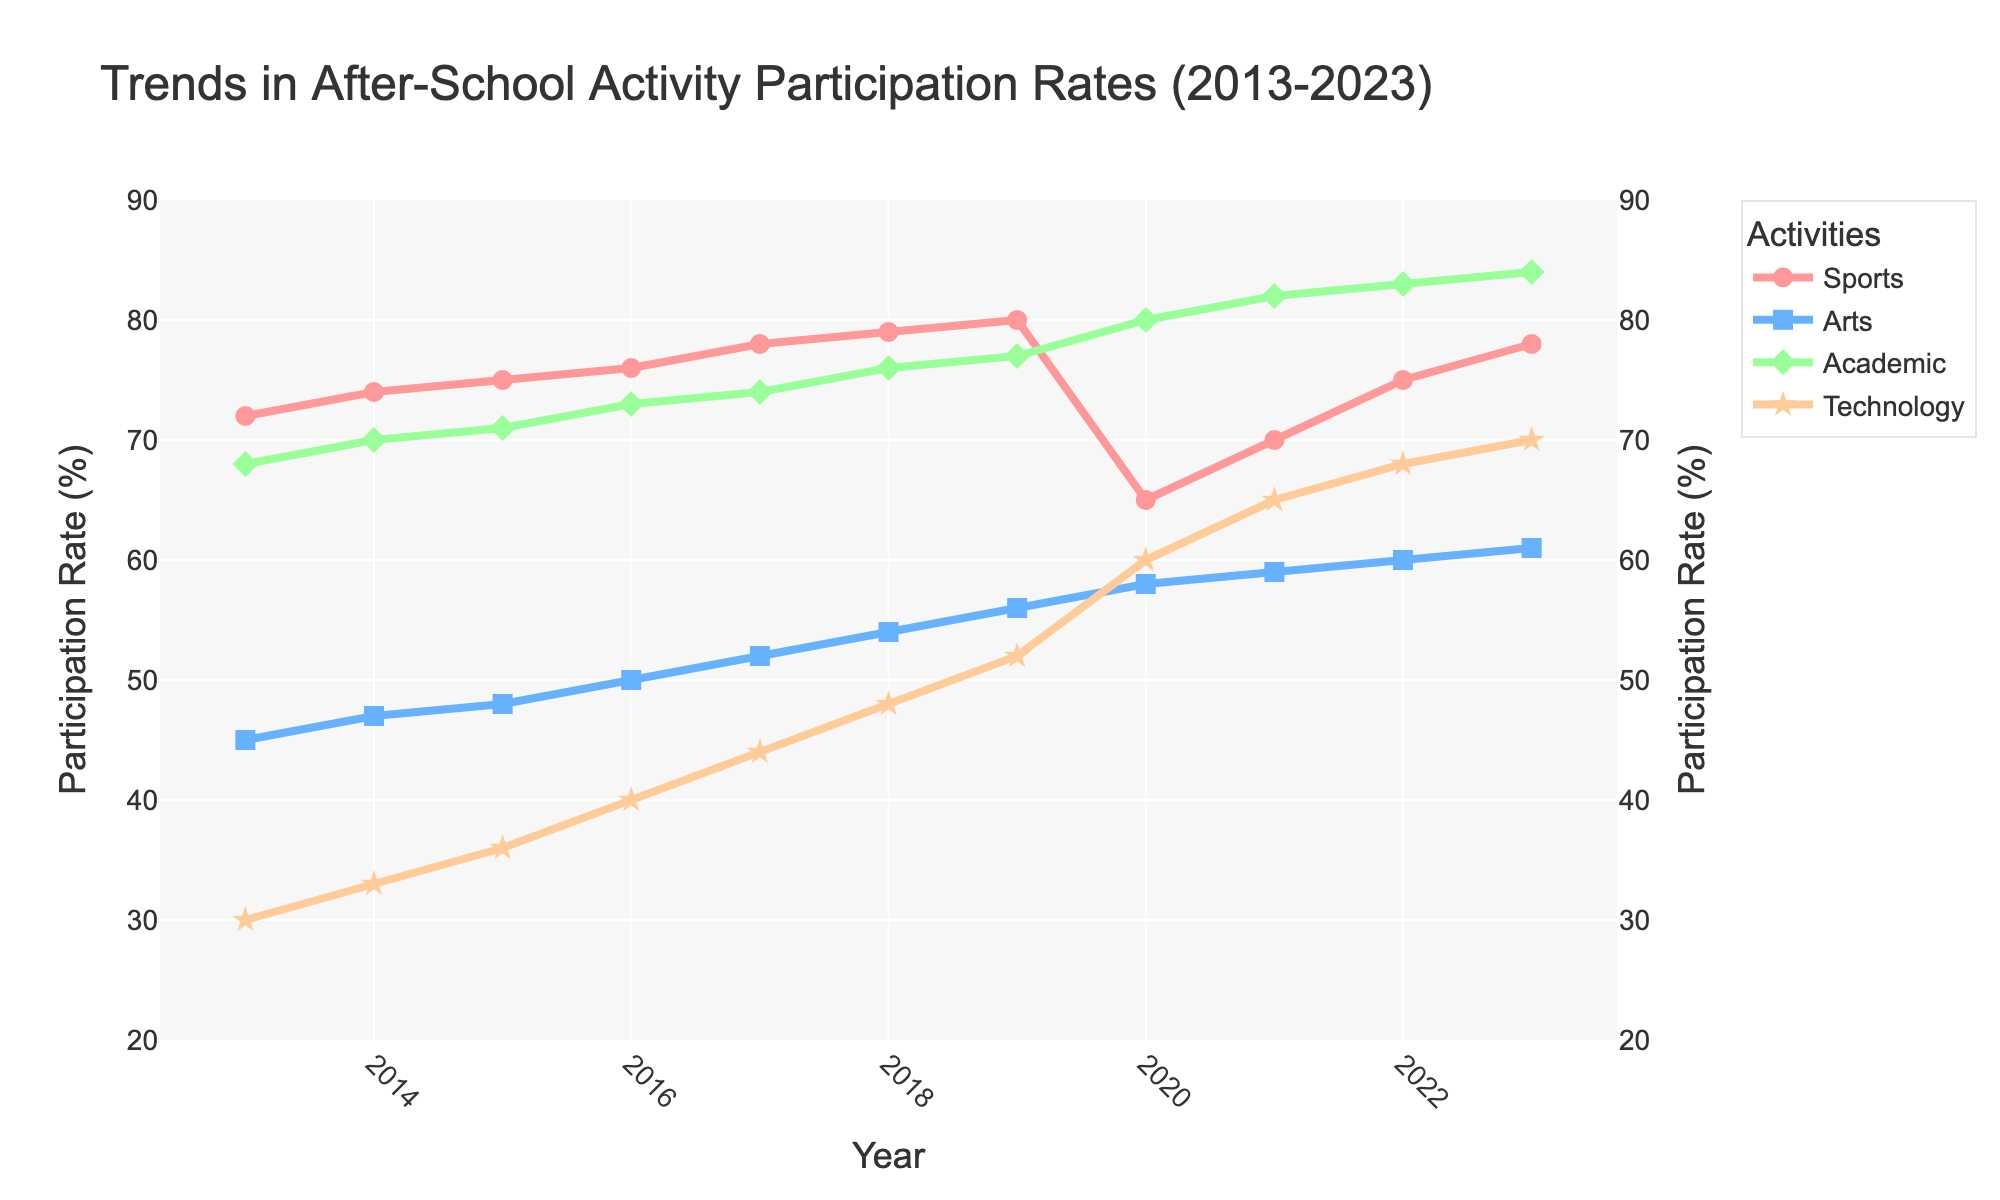what year had the highest participation rate in Technology? The highest line/marker for Technology in the chart will indicate the year with the highest participation rate. The highest point is at 2023.
Answer: 2023 Which activity had the highest overall participation rate in 2023? Compare the participation rates of the four activities (Sports, Arts, Academic, Technology) in 2023. The highest point is 84% for Academic.
Answer: Academic During which year did Sports participation experience a significant drop? Look for a sharp decline in the line representing Sports. In 2020, the participation rate dropped significantly to 65%.
Answer: 2020 How did the participation rates for Arts change from 2019 to 2021? Compare the rates at 2019, 2020, and 2021. The rates went from 56% in 2019 to 58% in 2020, and 59% in 2021, indicating a gradual increase.
Answer: Increased gradually Which activity saw the most consistent growth over the decade? Observe the slopes of the lines for each activity over the years. Academic shows a steady and consistent increase from 68% in 2013 to 84% in 2023.
Answer: Academic In which year did Technology participation overtake Sports participation? Identify the first instance where the line for Technology surpasses the line for Sports. In 2020, Technology participation (60%) overtakes Sports (65%).
Answer: 2020 What visual features differentiate the Academic and the Arts lines? Examine the shape and visual attributes of the lines. Academic is represented by green diamond markers, whereas Arts uses blue square markers.
Answer: Shape and color of markers What is the average participation rate for Sports from 2013 to 2023? Sum the Sports participation rates across the years and divide by the number of years: (72+74+75+76+78+79+80+65+70+75+78)/11. The calculation gives an average of approximately 74.
Answer: 74 How does the participation trend in Sports compare to Technology over the years? Compare the shapes and directions of the lines. Sports fluctuations include a notable dip in 2020 but generally grow, while Technology shows a steady increase, particularly after 2019.
Answer: Sports fluctuates, Technology steadily increases Which two activities had the closest participation rates in 2017? Compare the participation rates of all activities in 2017. Sports had 78%, Arts had 52%, Academic had 74%, and Technology had 44%. The closest rates are Sports and Academic (78% and 74%).
Answer: Sports and Academic 